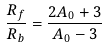<formula> <loc_0><loc_0><loc_500><loc_500>\frac { R _ { f } } { R _ { b } } = \frac { 2 A _ { 0 } + 3 } { A _ { 0 } - 3 }</formula> 